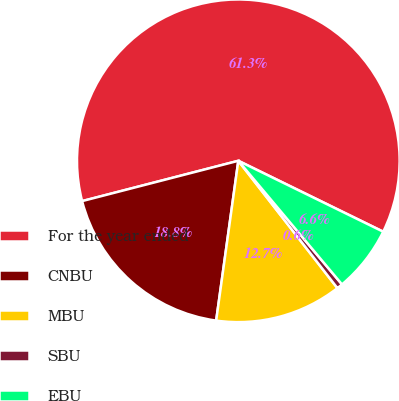<chart> <loc_0><loc_0><loc_500><loc_500><pie_chart><fcel>For the year ended<fcel>CNBU<fcel>MBU<fcel>SBU<fcel>EBU<nl><fcel>61.27%<fcel>18.79%<fcel>12.72%<fcel>0.58%<fcel>6.65%<nl></chart> 